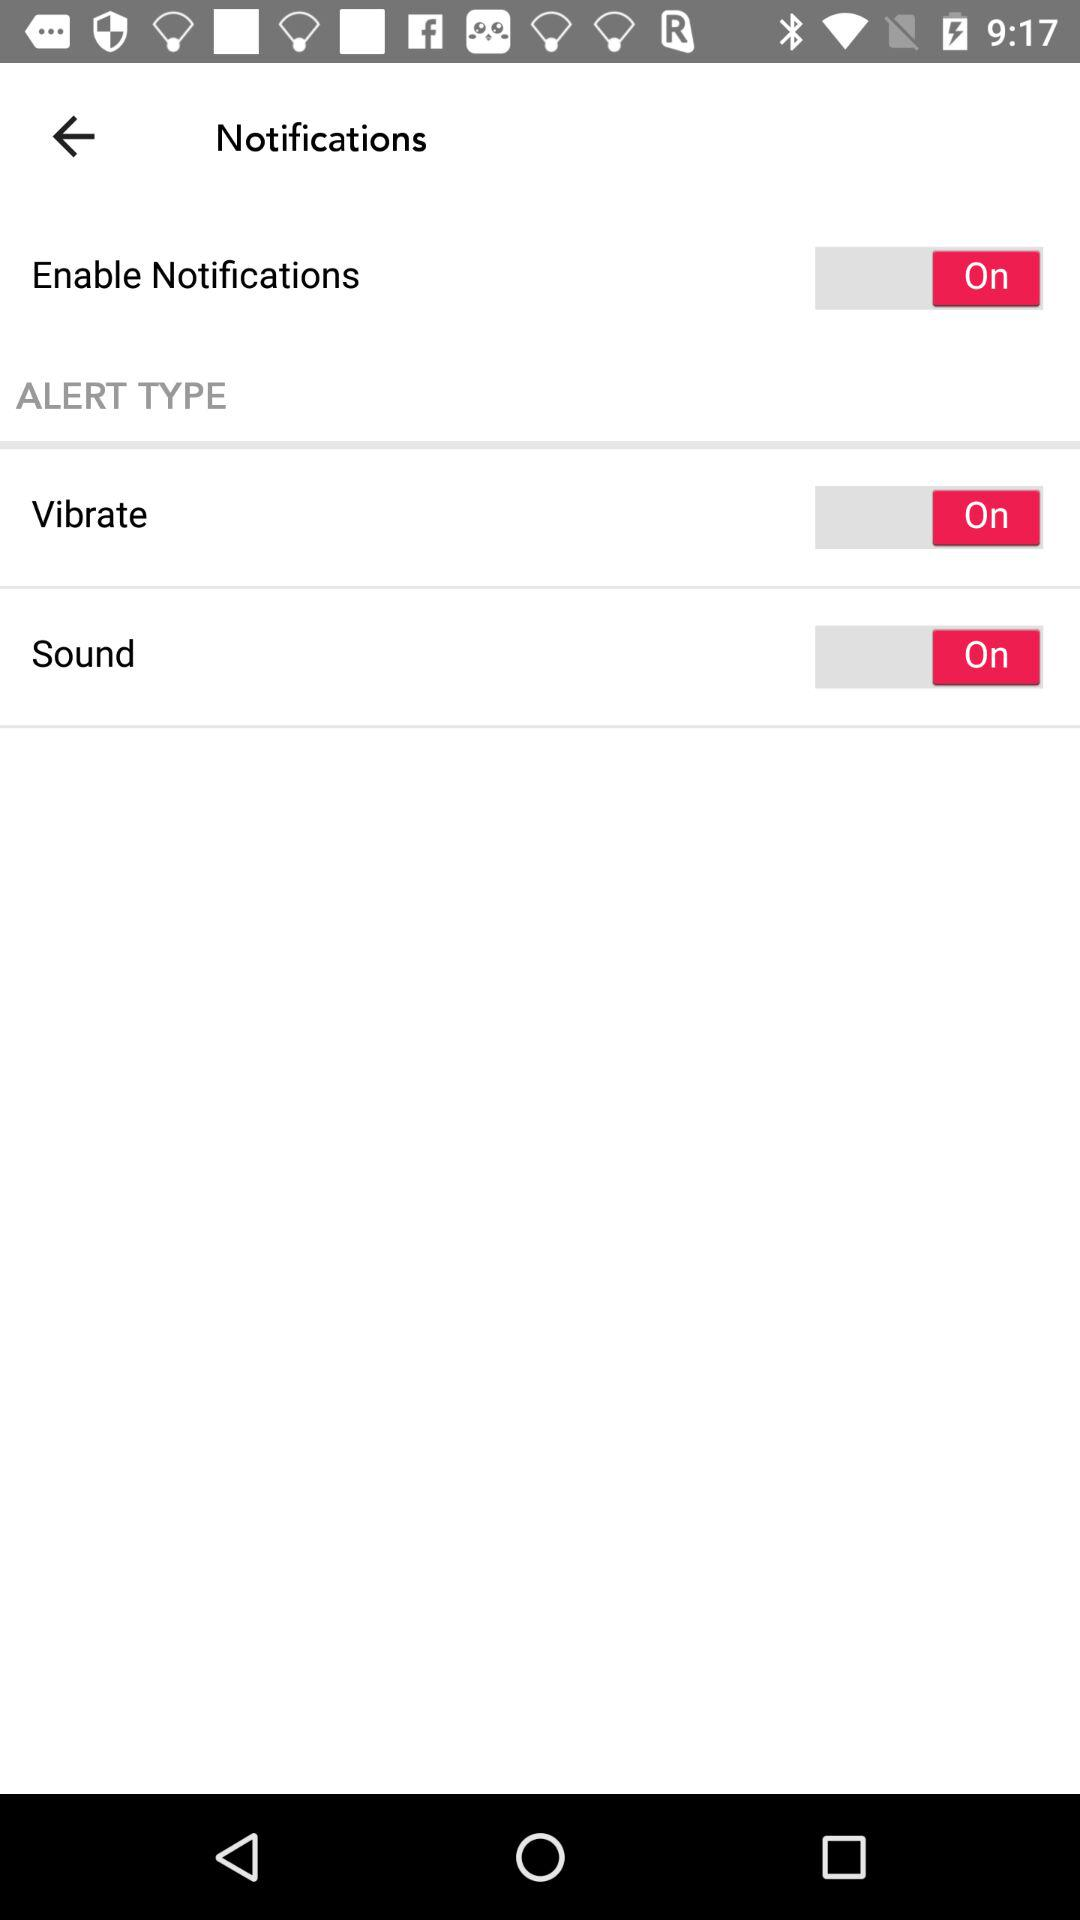What is the alert status of sound? The status is "on". 